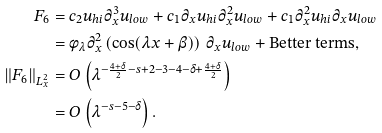<formula> <loc_0><loc_0><loc_500><loc_500>F _ { 6 } & = c _ { 2 } u _ { h i } \partial _ { x } ^ { 3 } u _ { l o w } + c _ { 1 } \partial _ { x } u _ { h i } \partial _ { x } ^ { 2 } u _ { l o w } + c _ { 1 } \partial _ { x } ^ { 2 } u _ { h i } \partial _ { x } u _ { l o w } \\ & = \phi _ { \lambda } \partial _ { x } ^ { 2 } \left ( \cos ( \lambda x + \beta ) \right ) \, \partial _ { x } u _ { l o w } + \text {Better terms} , \\ \| F _ { 6 } \| _ { L ^ { 2 } _ { x } } & = O \left ( \lambda ^ { - \frac { 4 + \delta } { 2 } - s + 2 - 3 - 4 - \delta + \frac { 4 + \delta } { 2 } } \right ) \\ & = O \left ( \lambda ^ { - s - 5 - \delta } \right ) .</formula> 